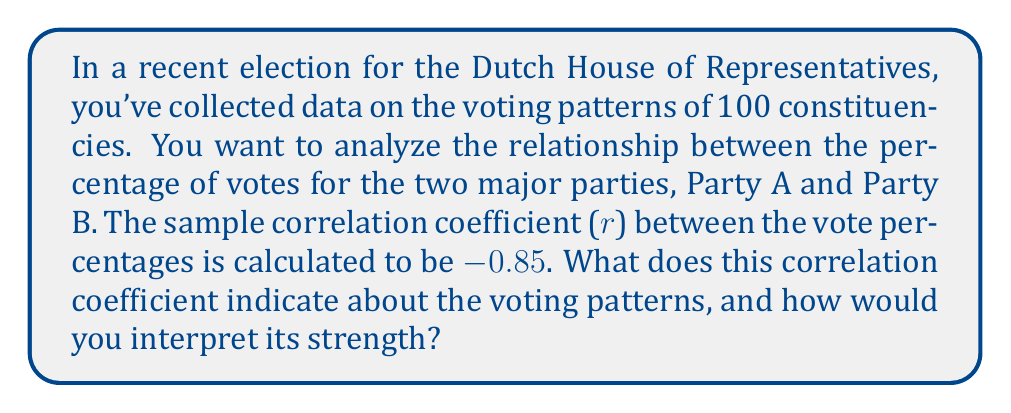Can you solve this math problem? To interpret the correlation coefficient, we need to understand its properties and meaning:

1. The correlation coefficient (r) ranges from -1 to +1.
2. The sign indicates the direction of the relationship:
   - Positive: As one variable increases, the other tends to increase.
   - Negative: As one variable increases, the other tends to decrease.
3. The magnitude indicates the strength of the relationship:
   - |r| = 1: Perfect correlation
   - 0.7 ≤ |r| < 1: Strong correlation
   - 0.5 ≤ |r| < 0.7: Moderate correlation
   - 0.3 ≤ |r| < 0.5: Weak correlation
   - 0 ≤ |r| < 0.3: Very weak to no correlation

In this case, r = -0.85. Let's interpret this:

1. The negative sign indicates an inverse relationship between the vote percentages for Party A and Party B.
2. The magnitude |r| = 0.85 falls in the range 0.7 ≤ |r| < 1, indicating a strong correlation.

To quantify the strength, we can calculate the coefficient of determination:

$$ R^2 = r^2 = (-0.85)^2 = 0.7225 $$

This means that approximately 72.25% of the variance in one party's vote percentage can be explained by the variance in the other party's vote percentage.

Interpretation: There is a strong negative correlation between the vote percentages for Party A and Party B. As the percentage of votes for one party increases, the percentage for the other party tends to decrease. This suggests that voters in these constituencies tend to favor one party over the other, with little split voting between the two major parties.
Answer: Strong negative correlation; as votes for one party increase, votes for the other decrease. 